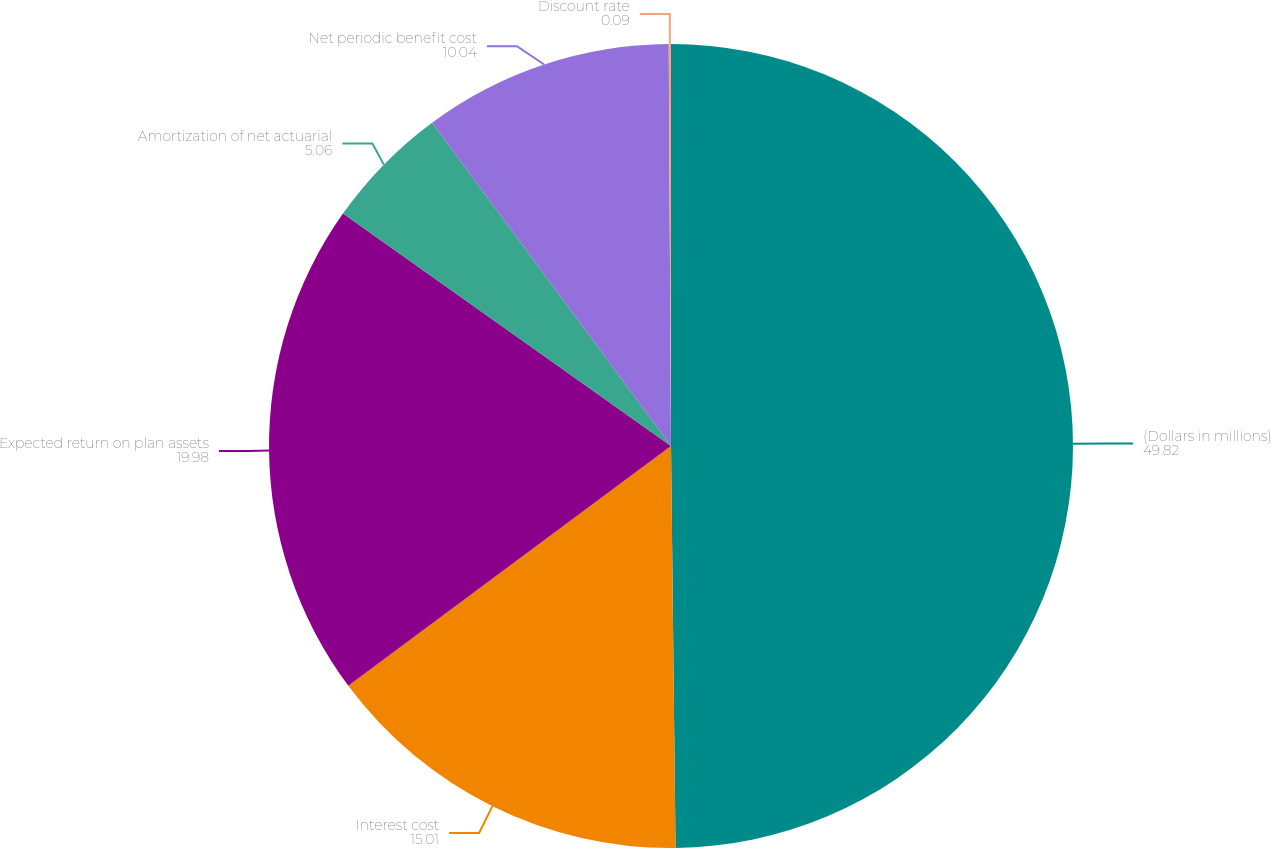<chart> <loc_0><loc_0><loc_500><loc_500><pie_chart><fcel>(Dollars in millions)<fcel>Interest cost<fcel>Expected return on plan assets<fcel>Amortization of net actuarial<fcel>Net periodic benefit cost<fcel>Discount rate<nl><fcel>49.82%<fcel>15.01%<fcel>19.98%<fcel>5.06%<fcel>10.04%<fcel>0.09%<nl></chart> 